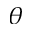Convert formula to latex. <formula><loc_0><loc_0><loc_500><loc_500>\theta</formula> 